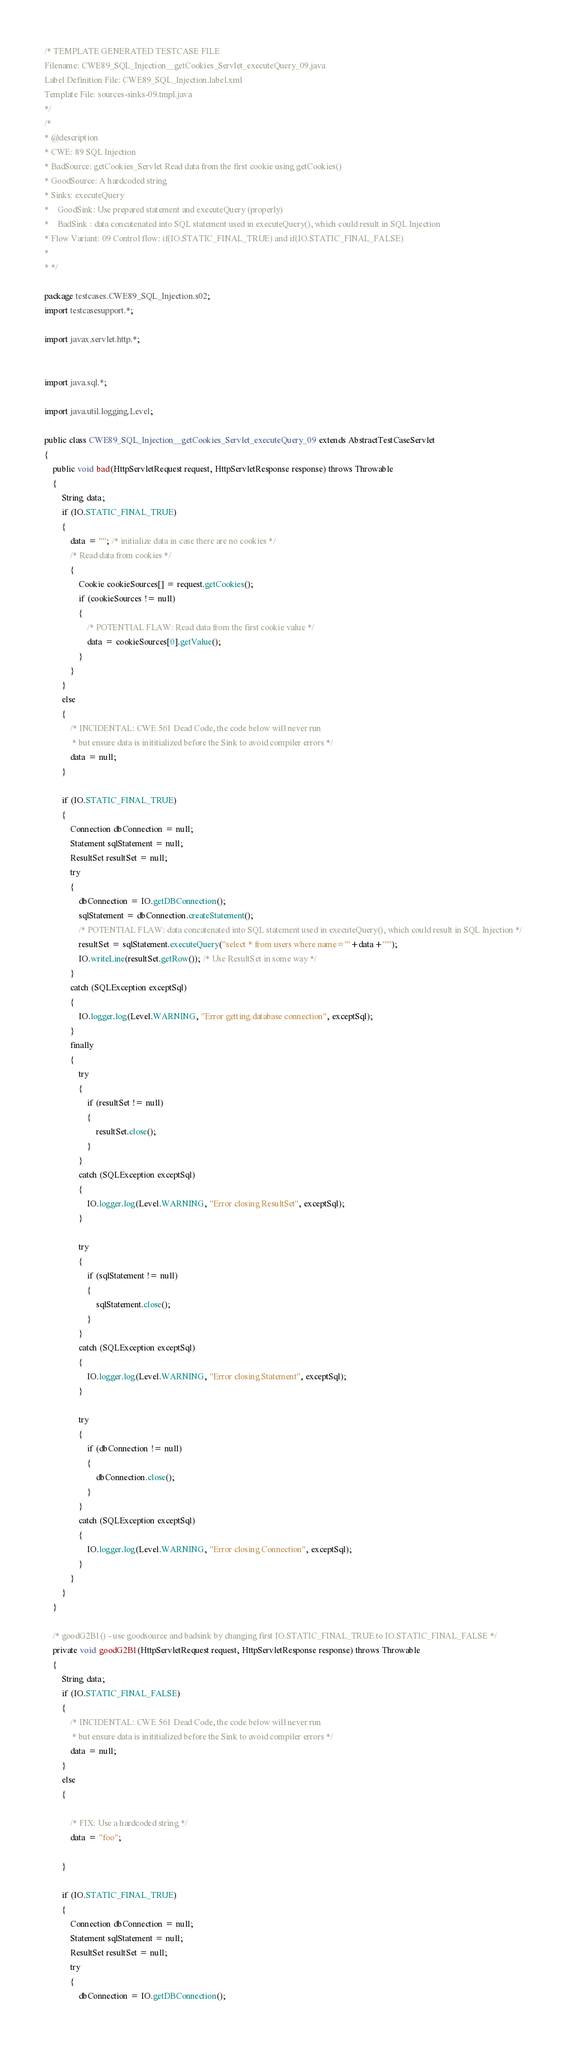<code> <loc_0><loc_0><loc_500><loc_500><_Java_>/* TEMPLATE GENERATED TESTCASE FILE
Filename: CWE89_SQL_Injection__getCookies_Servlet_executeQuery_09.java
Label Definition File: CWE89_SQL_Injection.label.xml
Template File: sources-sinks-09.tmpl.java
*/
/*
* @description
* CWE: 89 SQL Injection
* BadSource: getCookies_Servlet Read data from the first cookie using getCookies()
* GoodSource: A hardcoded string
* Sinks: executeQuery
*    GoodSink: Use prepared statement and executeQuery (properly)
*    BadSink : data concatenated into SQL statement used in executeQuery(), which could result in SQL Injection
* Flow Variant: 09 Control flow: if(IO.STATIC_FINAL_TRUE) and if(IO.STATIC_FINAL_FALSE)
*
* */

package testcases.CWE89_SQL_Injection.s02;
import testcasesupport.*;

import javax.servlet.http.*;


import java.sql.*;

import java.util.logging.Level;

public class CWE89_SQL_Injection__getCookies_Servlet_executeQuery_09 extends AbstractTestCaseServlet
{
    public void bad(HttpServletRequest request, HttpServletResponse response) throws Throwable
    {
        String data;
        if (IO.STATIC_FINAL_TRUE)
        {
            data = ""; /* initialize data in case there are no cookies */
            /* Read data from cookies */
            {
                Cookie cookieSources[] = request.getCookies();
                if (cookieSources != null)
                {
                    /* POTENTIAL FLAW: Read data from the first cookie value */
                    data = cookieSources[0].getValue();
                }
            }
        }
        else
        {
            /* INCIDENTAL: CWE 561 Dead Code, the code below will never run
             * but ensure data is inititialized before the Sink to avoid compiler errors */
            data = null;
        }

        if (IO.STATIC_FINAL_TRUE)
        {
            Connection dbConnection = null;
            Statement sqlStatement = null;
            ResultSet resultSet = null;
            try
            {
                dbConnection = IO.getDBConnection();
                sqlStatement = dbConnection.createStatement();
                /* POTENTIAL FLAW: data concatenated into SQL statement used in executeQuery(), which could result in SQL Injection */
                resultSet = sqlStatement.executeQuery("select * from users where name='"+data+"'");
                IO.writeLine(resultSet.getRow()); /* Use ResultSet in some way */
            }
            catch (SQLException exceptSql)
            {
                IO.logger.log(Level.WARNING, "Error getting database connection", exceptSql);
            }
            finally
            {
                try
                {
                    if (resultSet != null)
                    {
                        resultSet.close();
                    }
                }
                catch (SQLException exceptSql)
                {
                    IO.logger.log(Level.WARNING, "Error closing ResultSet", exceptSql);
                }

                try
                {
                    if (sqlStatement != null)
                    {
                        sqlStatement.close();
                    }
                }
                catch (SQLException exceptSql)
                {
                    IO.logger.log(Level.WARNING, "Error closing Statement", exceptSql);
                }

                try
                {
                    if (dbConnection != null)
                    {
                        dbConnection.close();
                    }
                }
                catch (SQLException exceptSql)
                {
                    IO.logger.log(Level.WARNING, "Error closing Connection", exceptSql);
                }
            }
        }
    }

    /* goodG2B1() - use goodsource and badsink by changing first IO.STATIC_FINAL_TRUE to IO.STATIC_FINAL_FALSE */
    private void goodG2B1(HttpServletRequest request, HttpServletResponse response) throws Throwable
    {
        String data;
        if (IO.STATIC_FINAL_FALSE)
        {
            /* INCIDENTAL: CWE 561 Dead Code, the code below will never run
             * but ensure data is inititialized before the Sink to avoid compiler errors */
            data = null;
        }
        else
        {

            /* FIX: Use a hardcoded string */
            data = "foo";

        }

        if (IO.STATIC_FINAL_TRUE)
        {
            Connection dbConnection = null;
            Statement sqlStatement = null;
            ResultSet resultSet = null;
            try
            {
                dbConnection = IO.getDBConnection();</code> 